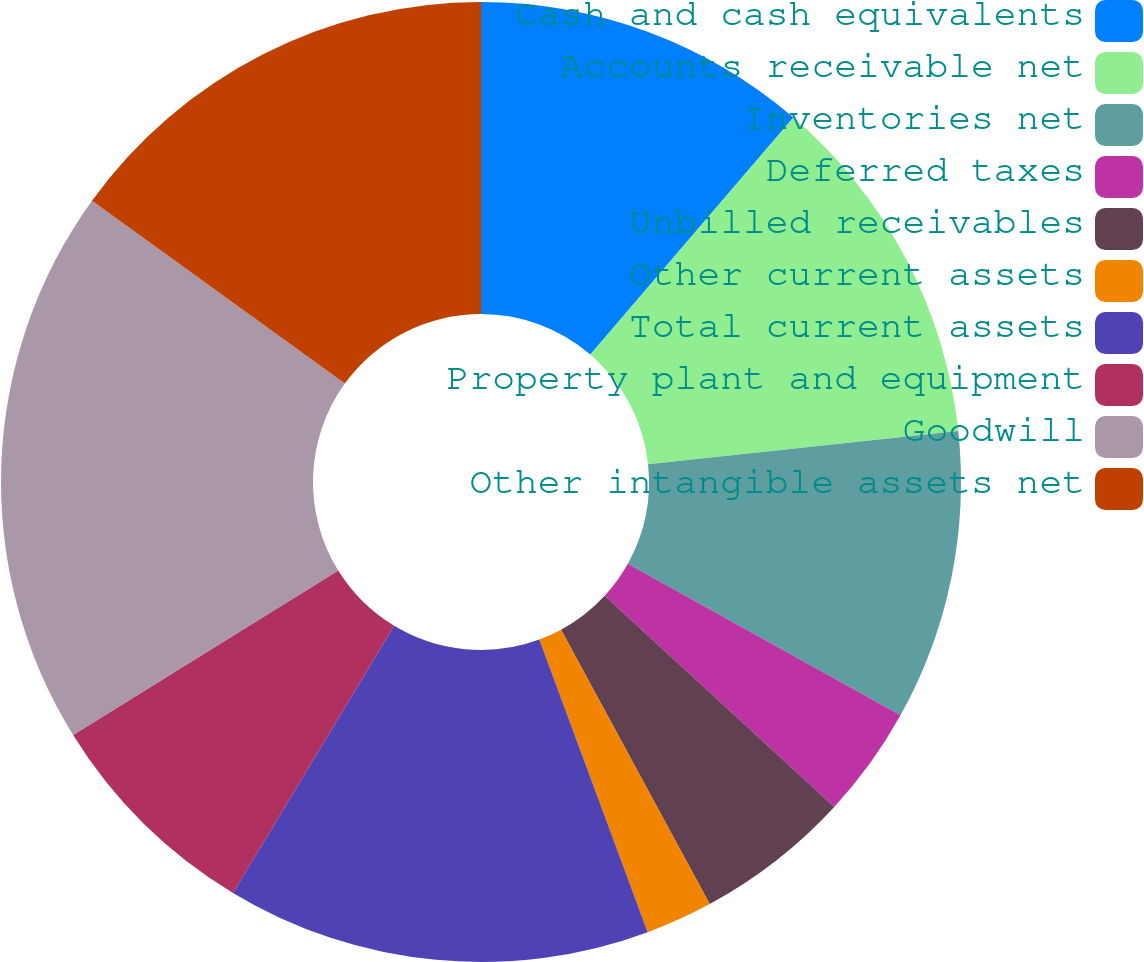Convert chart to OTSL. <chart><loc_0><loc_0><loc_500><loc_500><pie_chart><fcel>Cash and cash equivalents<fcel>Accounts receivable net<fcel>Inventories net<fcel>Deferred taxes<fcel>Unbilled receivables<fcel>Other current assets<fcel>Total current assets<fcel>Property plant and equipment<fcel>Goodwill<fcel>Other intangible assets net<nl><fcel>11.28%<fcel>12.03%<fcel>9.77%<fcel>3.76%<fcel>5.26%<fcel>2.26%<fcel>14.29%<fcel>7.52%<fcel>18.8%<fcel>15.04%<nl></chart> 